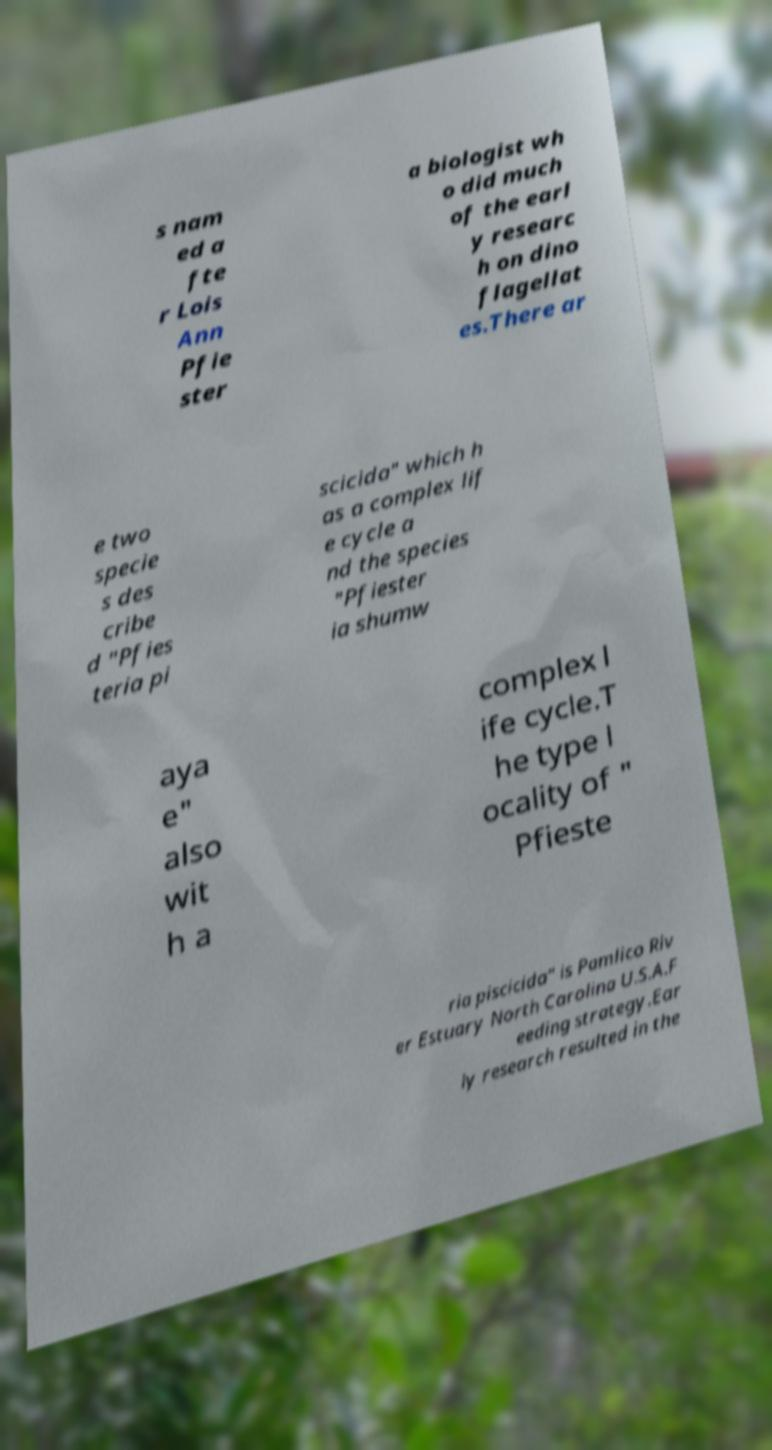Please read and relay the text visible in this image. What does it say? s nam ed a fte r Lois Ann Pfie ster a biologist wh o did much of the earl y researc h on dino flagellat es.There ar e two specie s des cribe d "Pfies teria pi scicida" which h as a complex lif e cycle a nd the species "Pfiester ia shumw aya e" also wit h a complex l ife cycle.T he type l ocality of " Pfieste ria piscicida" is Pamlico Riv er Estuary North Carolina U.S.A.F eeding strategy.Ear ly research resulted in the 